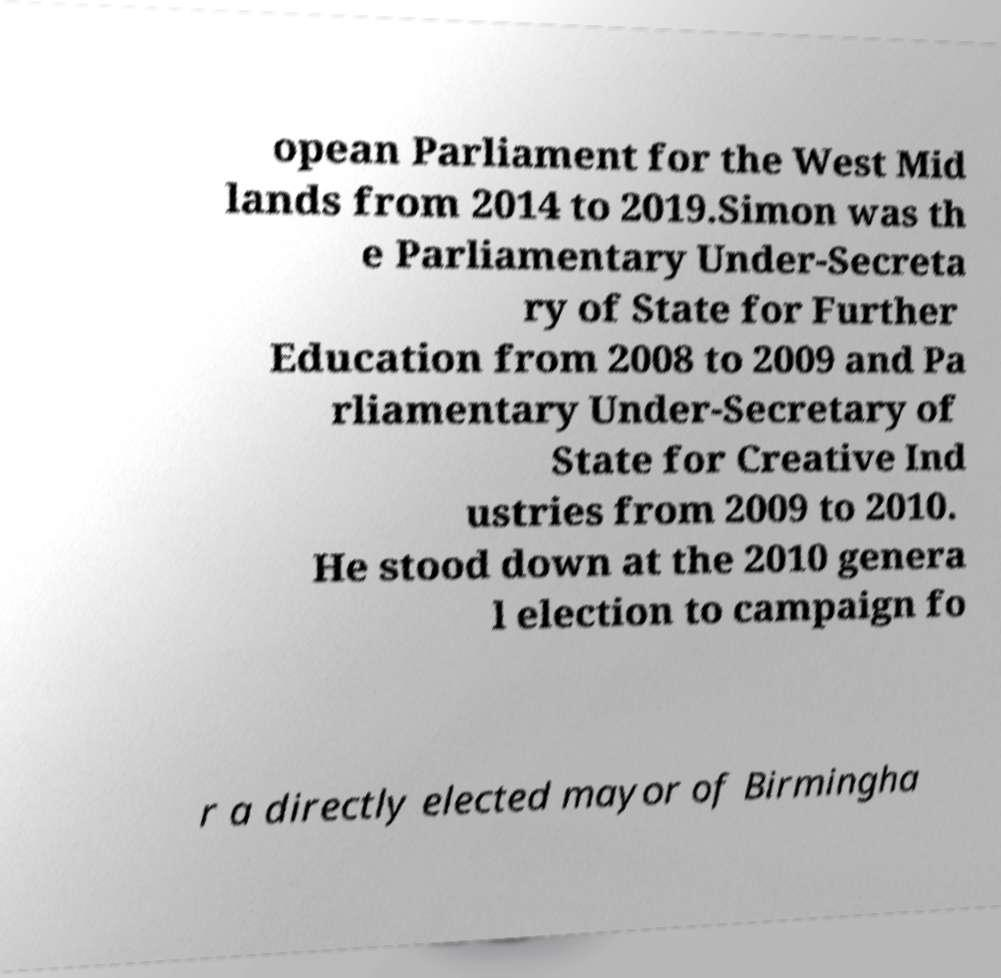Please identify and transcribe the text found in this image. opean Parliament for the West Mid lands from 2014 to 2019.Simon was th e Parliamentary Under-Secreta ry of State for Further Education from 2008 to 2009 and Pa rliamentary Under-Secretary of State for Creative Ind ustries from 2009 to 2010. He stood down at the 2010 genera l election to campaign fo r a directly elected mayor of Birmingha 